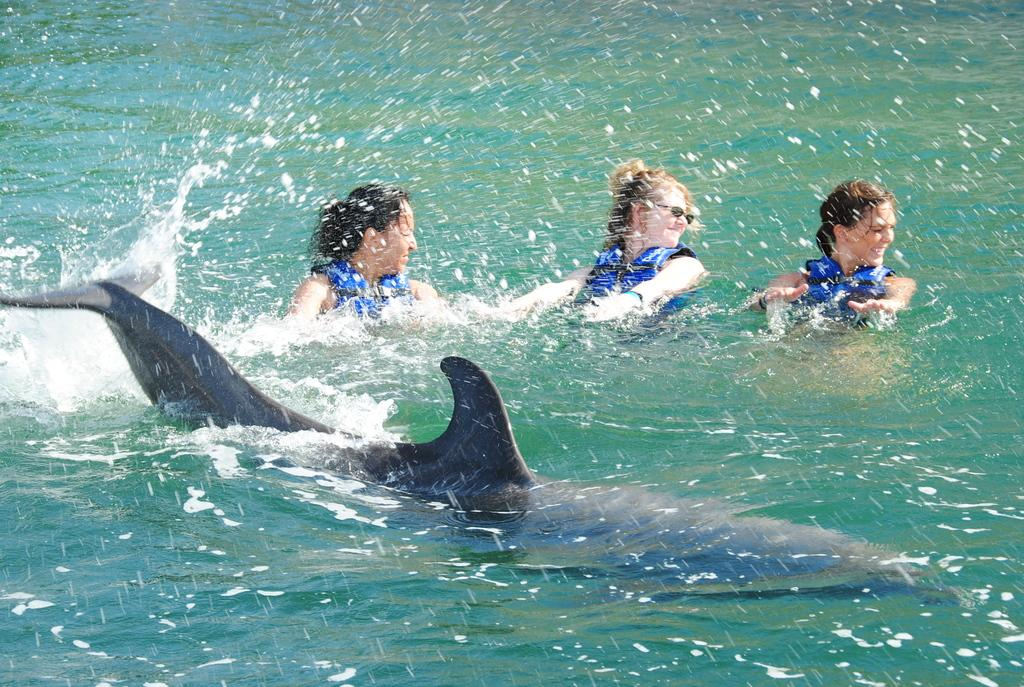What animal can be seen swimming in the water in the image? There is a dolphin swimming in the water in the image. How many women are present in the image? There are three women in the image. What are the women wearing that might provide safety or buoyancy? The women are wearing blue life jackets. In which direction are the women looking? The women are looking to the right side. What type of mint can be seen growing near the women in the image? There is no mint present in the image; it features a dolphin swimming in the water and three women wearing blue life jackets. What color is the hair of the woman on the left side of the image? There is no woman on the left side of the image, as the women are facing to the right side. 